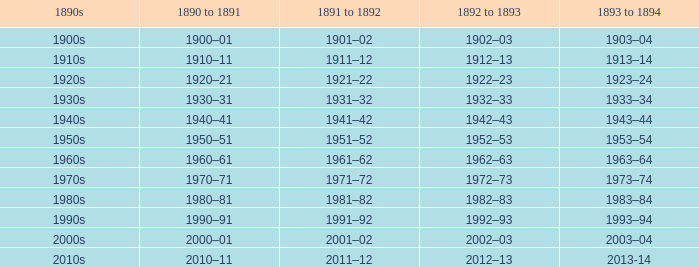What years from 1893-94 that is from the 1890s to the 1990s? 1993–94. 